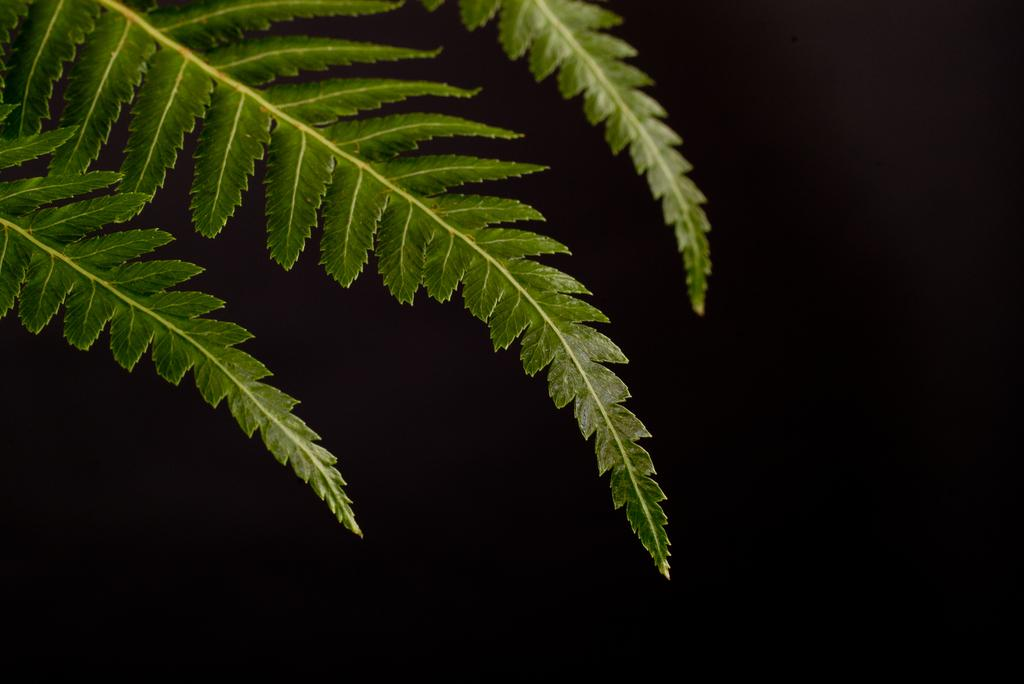What type of vegetation is visible in the image? There are leaves in the image. What is the color of the background in the image? The background of the image is dark. How many giants can be seen walking through the leaves in the image? There are no giants present in the image; it only features leaves. What type of beast is visible in the image? There is no beast present in the image; it only features leaves. Is there a kite flying in the image? There is no kite present in the image; it only features leaves. 